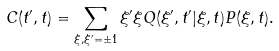<formula> <loc_0><loc_0><loc_500><loc_500>C ( t ^ { \prime } , t ) = \sum _ { \xi , \xi ^ { \prime } = \pm 1 } \xi ^ { \prime } \xi Q ( \xi ^ { \prime } , t ^ { \prime } | \xi , t ) P ( \xi , t ) .</formula> 